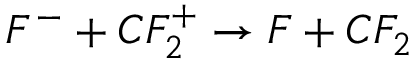Convert formula to latex. <formula><loc_0><loc_0><loc_500><loc_500>F ^ { - } + C F _ { 2 } ^ { + } \rightarrow F + C F _ { 2 }</formula> 